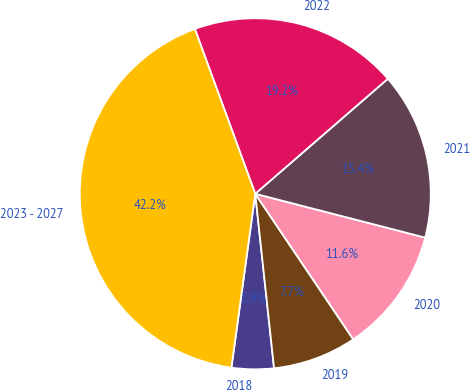<chart> <loc_0><loc_0><loc_500><loc_500><pie_chart><fcel>2018<fcel>2019<fcel>2020<fcel>2021<fcel>2022<fcel>2023 - 2027<nl><fcel>3.88%<fcel>7.72%<fcel>11.55%<fcel>15.39%<fcel>19.22%<fcel>42.24%<nl></chart> 